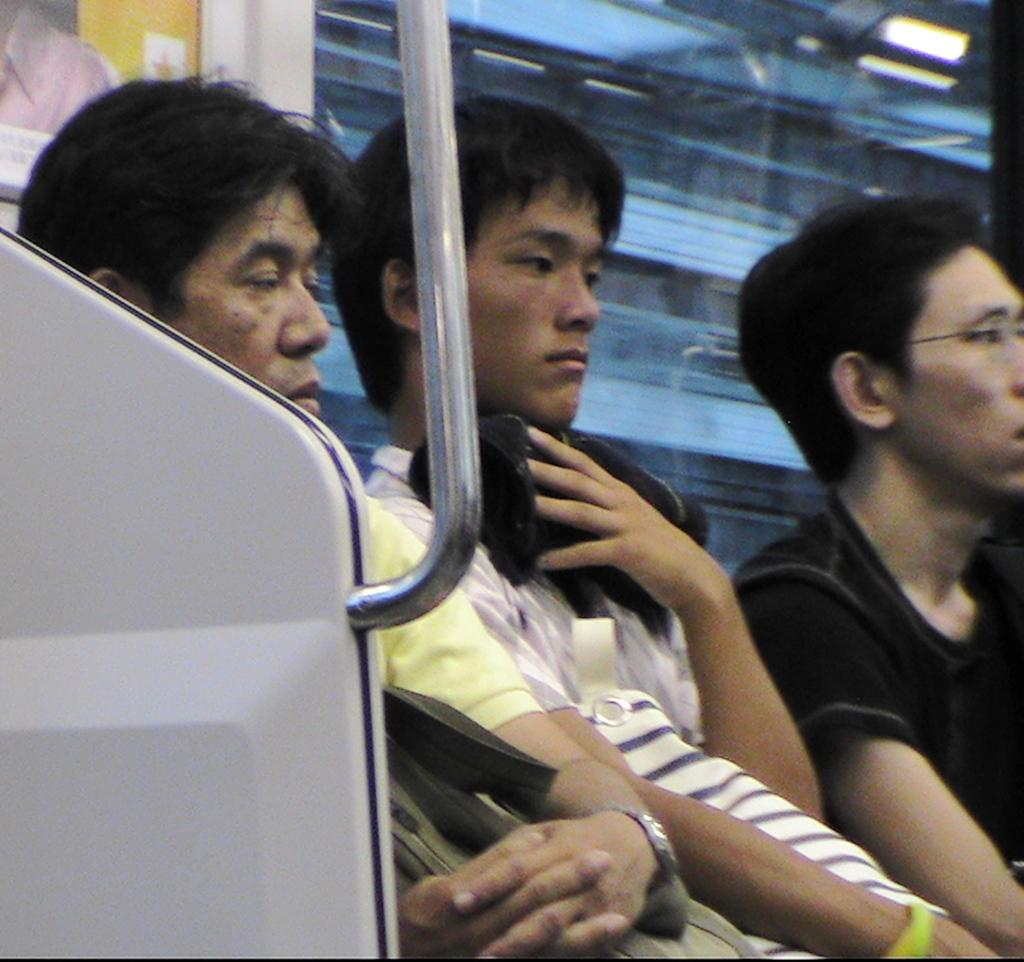How many people are sitting in the image? There are three men sitting in the image. What is one of the men doing with his hands? One of the men is holding an object. What type of structure can be seen in the image? There is a metal pole in the image. What material is the window made of in the image? There is a glass window in the image. What type of pie is being shared among the men in the image? There is no pie present in the image; the men are not sharing any food. How do the men plan to join their forces after the meeting in the image? The image does not depict a meeting or any indication of the men joining forces; it only shows them sitting. 